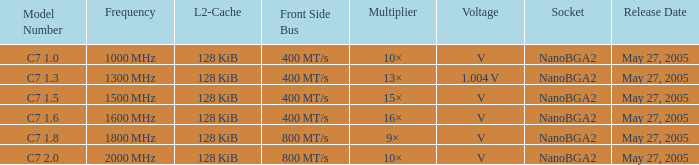What is the Release Date for Model Number c7 1.8? May 27, 2005. 